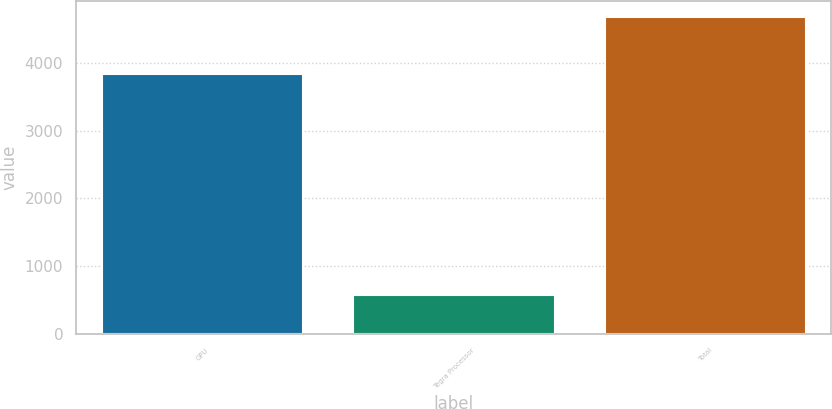Convert chart. <chart><loc_0><loc_0><loc_500><loc_500><bar_chart><fcel>GPU<fcel>Tegra Processor<fcel>Total<nl><fcel>3839<fcel>579<fcel>4682<nl></chart> 